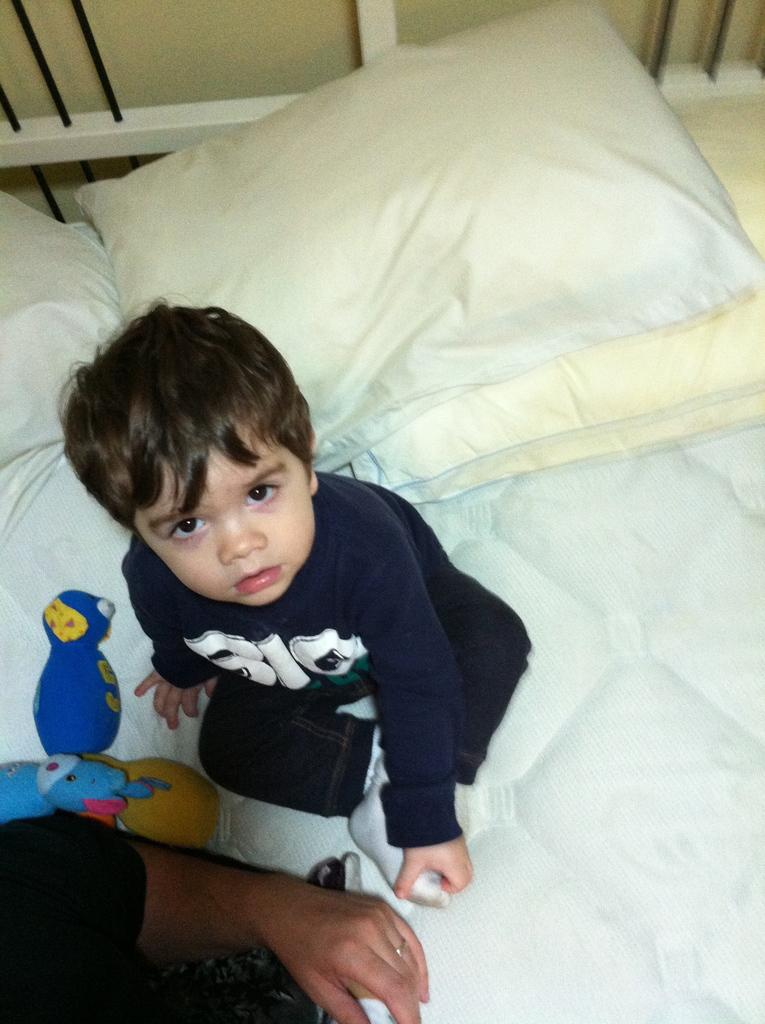Who is in the image? There is a boy in the image. What is the boy doing in the image? The boy is sitting on a bed. Can you describe any specific features of the bed? The bed has white color windows. What type of answer can be seen in the boy's pocket in the image? There is no answer or pocket visible in the image; it only shows a boy sitting on a bed with white color windows. 